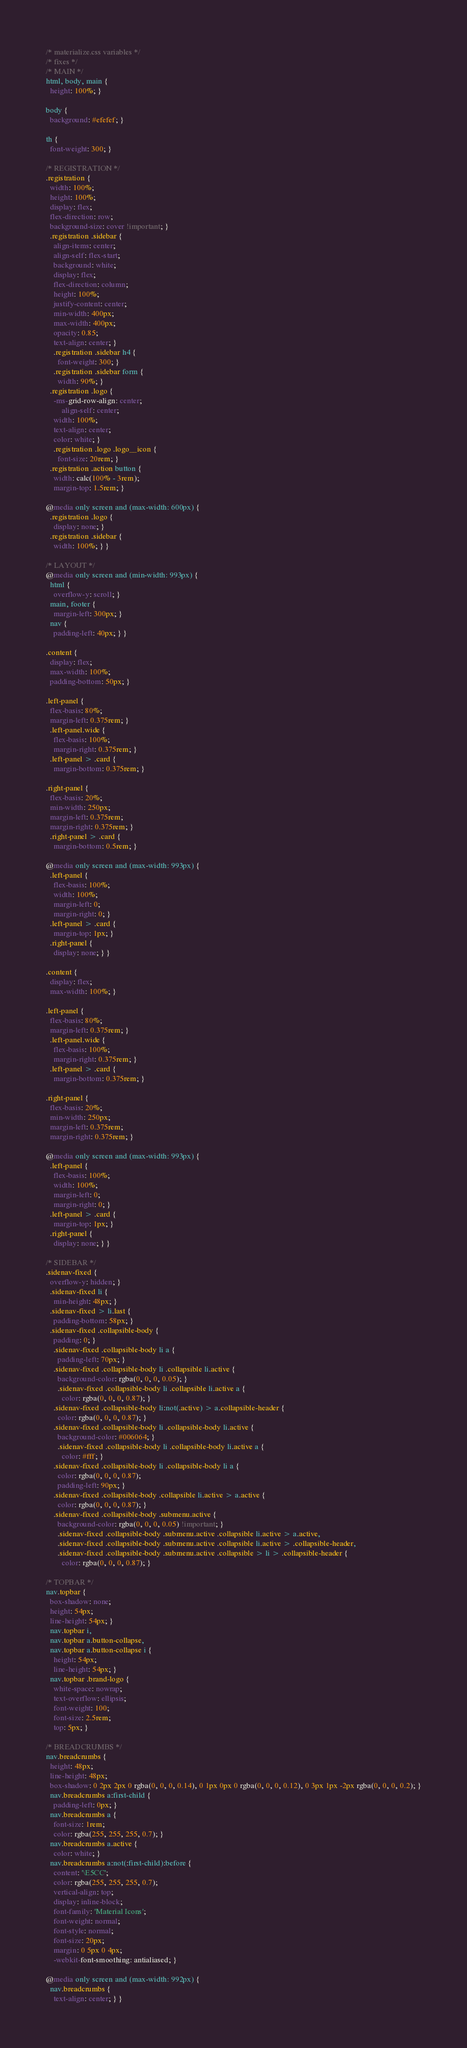<code> <loc_0><loc_0><loc_500><loc_500><_CSS_>/* materialize.css variables */
/* fixes */
/* MAIN */
html, body, main {
  height: 100%; }

body {
  background: #efefef; }

th {
  font-weight: 300; }

/* REGISTRATION */
.registration {
  width: 100%;
  height: 100%;
  display: flex;
  flex-direction: row;
  background-size: cover !important; }
  .registration .sidebar {
    align-items: center;
    align-self: flex-start;
    background: white;
    display: flex;
    flex-direction: column;
    height: 100%;
    justify-content: center;
    min-width: 400px;
    max-width: 400px;
    opacity: 0.85;
    text-align: center; }
    .registration .sidebar h4 {
      font-weight: 300; }
    .registration .sidebar form {
      width: 90%; }
  .registration .logo {
    -ms-grid-row-align: center;
        align-self: center;
    width: 100%;
    text-align: center;
    color: white; }
    .registration .logo .logo__icon {
      font-size: 20rem; }
  .registration .action button {
    width: calc(100% - 3rem);
    margin-top: 1.5rem; }

@media only screen and (max-width: 600px) {
  .registration .logo {
    display: none; }
  .registration .sidebar {
    width: 100%; } }

/* LAYOUT */
@media only screen and (min-width: 993px) {
  html {
    overflow-y: scroll; }
  main, footer {
    margin-left: 300px; }
  nav {
    padding-left: 40px; } }

.content {
  display: flex;
  max-width: 100%;
  padding-bottom: 50px; }

.left-panel {
  flex-basis: 80%;
  margin-left: 0.375rem; }
  .left-panel.wide {
    flex-basis: 100%;
    margin-right: 0.375rem; }
  .left-panel > .card {
    margin-bottom: 0.375rem; }

.right-panel {
  flex-basis: 20%;
  min-width: 250px;
  margin-left: 0.375rem;
  margin-right: 0.375rem; }
  .right-panel > .card {
    margin-bottom: 0.5rem; }

@media only screen and (max-width: 993px) {
  .left-panel {
    flex-basis: 100%;
    width: 100%;
    margin-left: 0;
    margin-right: 0; }
  .left-panel > .card {
    margin-top: 1px; }
  .right-panel {
    display: none; } }

.content {
  display: flex;
  max-width: 100%; }

.left-panel {
  flex-basis: 80%;
  margin-left: 0.375rem; }
  .left-panel.wide {
    flex-basis: 100%;
    margin-right: 0.375rem; }
  .left-panel > .card {
    margin-bottom: 0.375rem; }

.right-panel {
  flex-basis: 20%;
  min-width: 250px;
  margin-left: 0.375rem;
  margin-right: 0.375rem; }

@media only screen and (max-width: 993px) {
  .left-panel {
    flex-basis: 100%;
    width: 100%;
    margin-left: 0;
    margin-right: 0; }
  .left-panel > .card {
    margin-top: 1px; }
  .right-panel {
    display: none; } }

/* SIDEBAR */
.sidenav-fixed {
  overflow-y: hidden; }
  .sidenav-fixed li {
    min-height: 48px; }
  .sidenav-fixed > li.last {
    padding-bottom: 58px; }
  .sidenav-fixed .collapsible-body {
    padding: 0; }
    .sidenav-fixed .collapsible-body li a {
      padding-left: 70px; }
    .sidenav-fixed .collapsible-body li .collapsible li.active {
      background-color: rgba(0, 0, 0, 0.05); }
      .sidenav-fixed .collapsible-body li .collapsible li.active a {
        color: rgba(0, 0, 0, 0.87); }
    .sidenav-fixed .collapsible-body li:not(.active) > a.collapsible-header {
      color: rgba(0, 0, 0, 0.87); }
    .sidenav-fixed .collapsible-body li .collapsible-body li.active {
      background-color: #006064; }
      .sidenav-fixed .collapsible-body li .collapsible-body li.active a {
        color: #fff; }
    .sidenav-fixed .collapsible-body li .collapsible-body li a {
      color: rgba(0, 0, 0, 0.87);
      padding-left: 90px; }
    .sidenav-fixed .collapsible-body .collapsible li.active > a.active {
      color: rgba(0, 0, 0, 0.87); }
    .sidenav-fixed .collapsible-body .submenu.active {
      background-color: rgba(0, 0, 0, 0.05) !important; }
      .sidenav-fixed .collapsible-body .submenu.active .collapsible li.active > a.active,
      .sidenav-fixed .collapsible-body .submenu.active .collapsible li.active > .collapsible-header,
      .sidenav-fixed .collapsible-body .submenu.active .collapsible > li > .collapsible-header {
        color: rgba(0, 0, 0, 0.87); }

/* TOPBAR */
nav.topbar {
  box-shadow: none;
  height: 54px;
  line-height: 54px; }
  nav.topbar i,
  nav.topbar a.button-collapse,
  nav.topbar a.button-collapse i {
    height: 54px;
    line-height: 54px; }
  nav.topbar .brand-logo {
    white-space: nowrap;
    text-overflow: ellipsis;
    font-weight: 100;
    font-size: 2.5rem;
    top: 5px; }

/* BREADCRUMBS */
nav.breadcrumbs {
  height: 48px;
  line-height: 48px;
  box-shadow: 0 2px 2px 0 rgba(0, 0, 0, 0.14), 0 1px 0px 0 rgba(0, 0, 0, 0.12), 0 3px 1px -2px rgba(0, 0, 0, 0.2); }
  nav.breadcrumbs a:first-child {
    padding-left: 0px; }
  nav.breadcrumbs a {
    font-size: 1rem;
    color: rgba(255, 255, 255, 0.7); }
  nav.breadcrumbs a.active {
    color: white; }
  nav.breadcrumbs a:not(:first-child):before {
    content: '\E5CC';
    color: rgba(255, 255, 255, 0.7);
    vertical-align: top;
    display: inline-block;
    font-family: 'Material Icons';
    font-weight: normal;
    font-style: normal;
    font-size: 20px;
    margin: 0 5px 0 4px;
    -webkit-font-smoothing: antialiased; }

@media only screen and (max-width: 992px) {
  nav.breadcrumbs {
    text-align: center; } }
</code> 